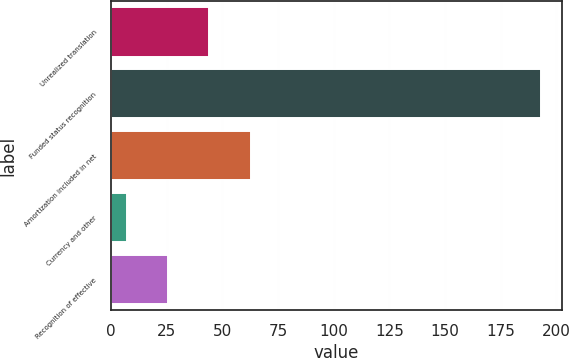Convert chart. <chart><loc_0><loc_0><loc_500><loc_500><bar_chart><fcel>Unrealized translation<fcel>Funded status recognition<fcel>Amortization included in net<fcel>Currency and other<fcel>Recognition of effective<nl><fcel>44.2<fcel>193<fcel>62.8<fcel>7<fcel>25.6<nl></chart> 